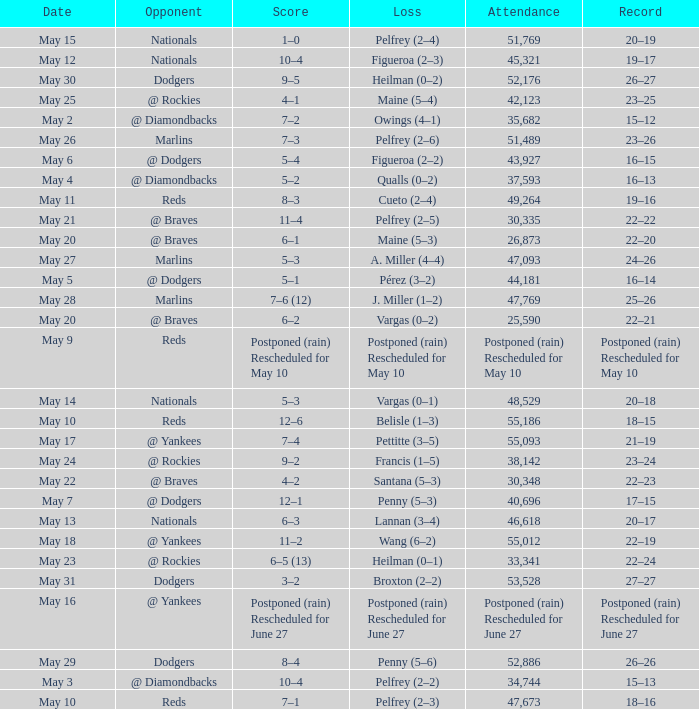Record of 19–16 occurred on what date? May 11. 